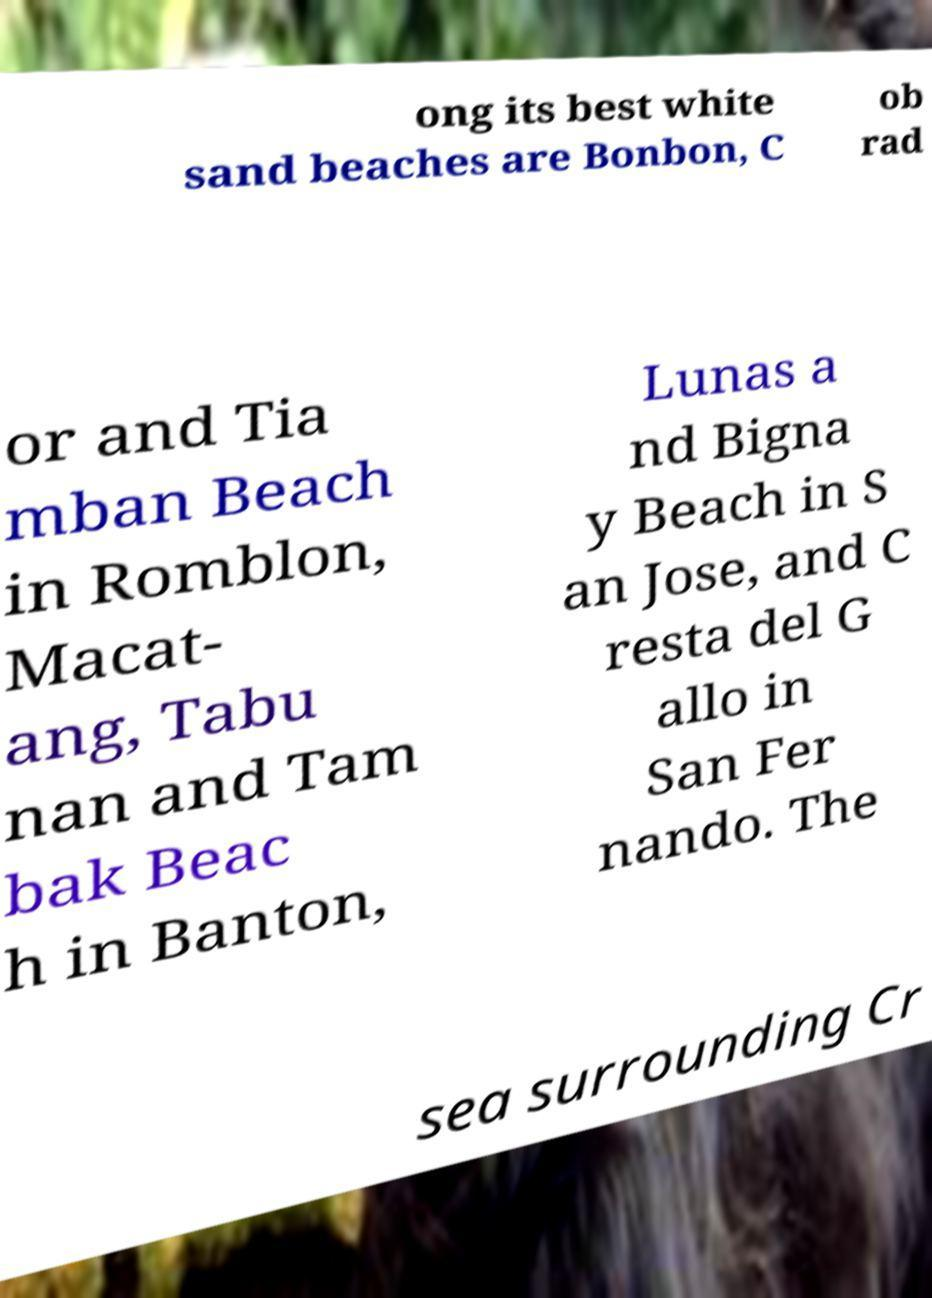What messages or text are displayed in this image? I need them in a readable, typed format. ong its best white sand beaches are Bonbon, C ob rad or and Tia mban Beach in Romblon, Macat- ang, Tabu nan and Tam bak Beac h in Banton, Lunas a nd Bigna y Beach in S an Jose, and C resta del G allo in San Fer nando. The sea surrounding Cr 